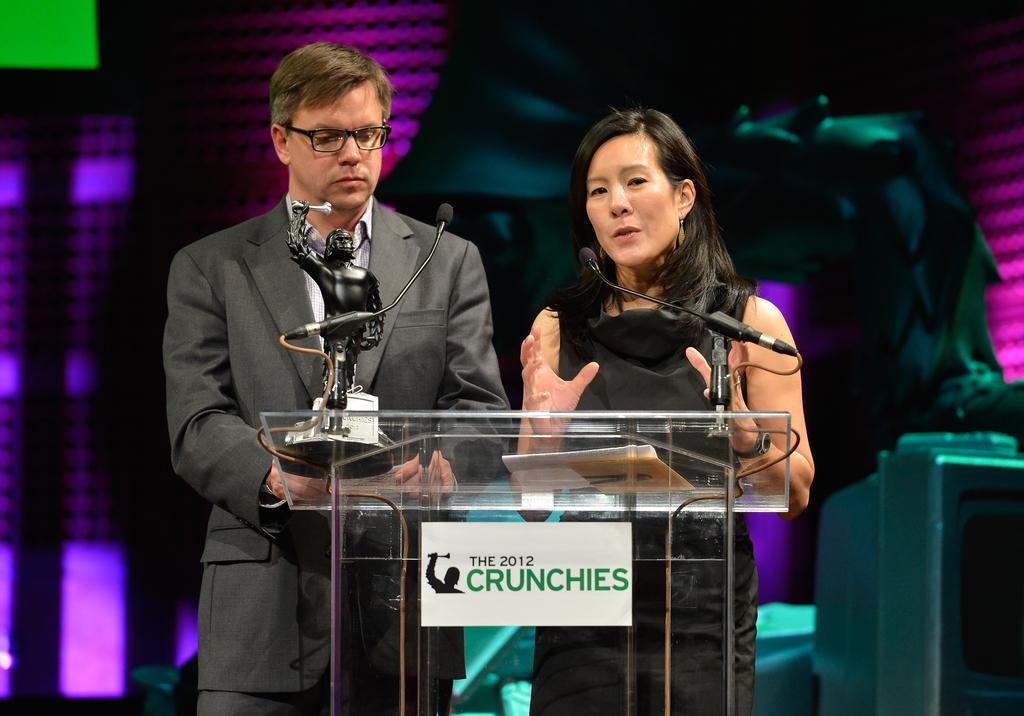How many people are in the image? There are two people in the image, a man and a woman. What are the man and the woman doing in the image? Both the man and the woman are standing behind a podium. What is in front of the podium? There are mice and a trophy in front of the podium. What is the woman doing in the image? The woman is talking. What can be seen in the background of the image? There are lights visible in the background of the image. What type of brush is being used by the man in the image? There is no brush present in the image. 